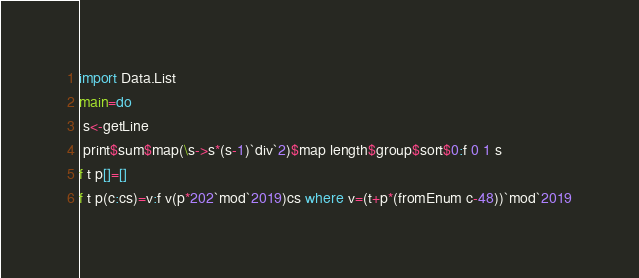Convert code to text. <code><loc_0><loc_0><loc_500><loc_500><_Haskell_>import Data.List
main=do
 s<-getLine
 print$sum$map(\s->s*(s-1)`div`2)$map length$group$sort$0:f 0 1 s
f t p[]=[]
f t p(c:cs)=v:f v(p*202`mod`2019)cs where v=(t+p*(fromEnum c-48))`mod`2019</code> 